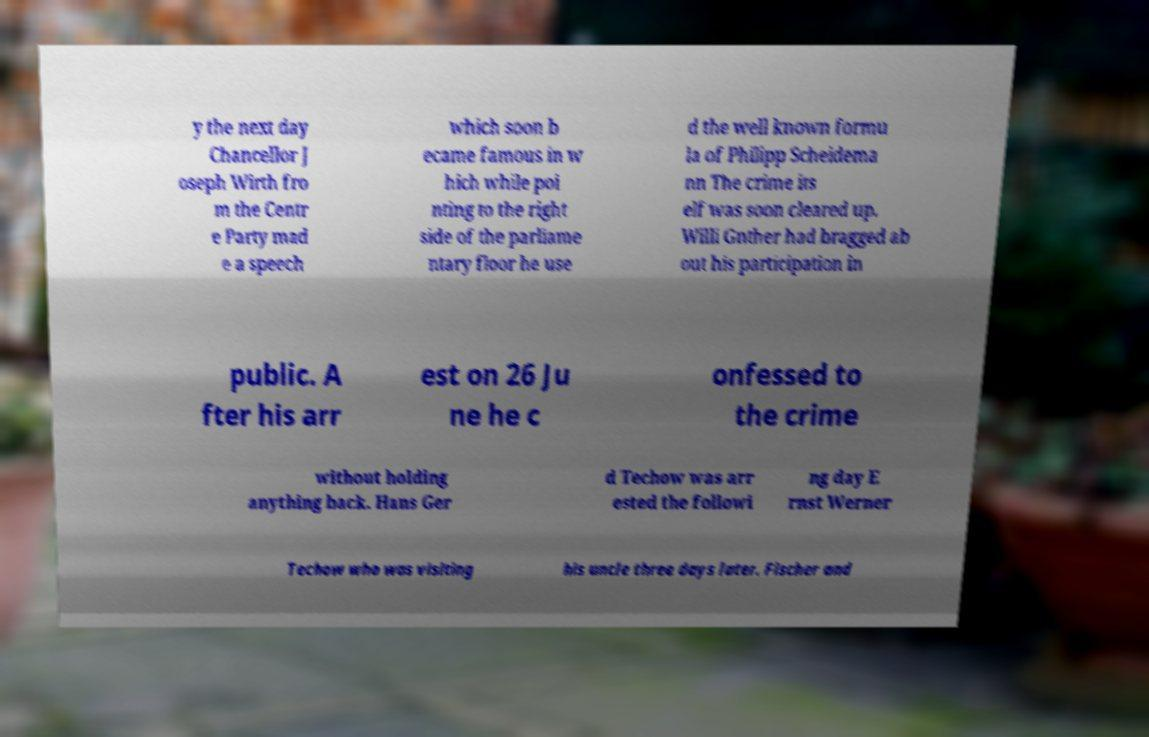Could you extract and type out the text from this image? y the next day Chancellor J oseph Wirth fro m the Centr e Party mad e a speech which soon b ecame famous in w hich while poi nting to the right side of the parliame ntary floor he use d the well known formu la of Philipp Scheidema nn The crime its elf was soon cleared up. Willi Gnther had bragged ab out his participation in public. A fter his arr est on 26 Ju ne he c onfessed to the crime without holding anything back. Hans Ger d Techow was arr ested the followi ng day E rnst Werner Techow who was visiting his uncle three days later. Fischer and 